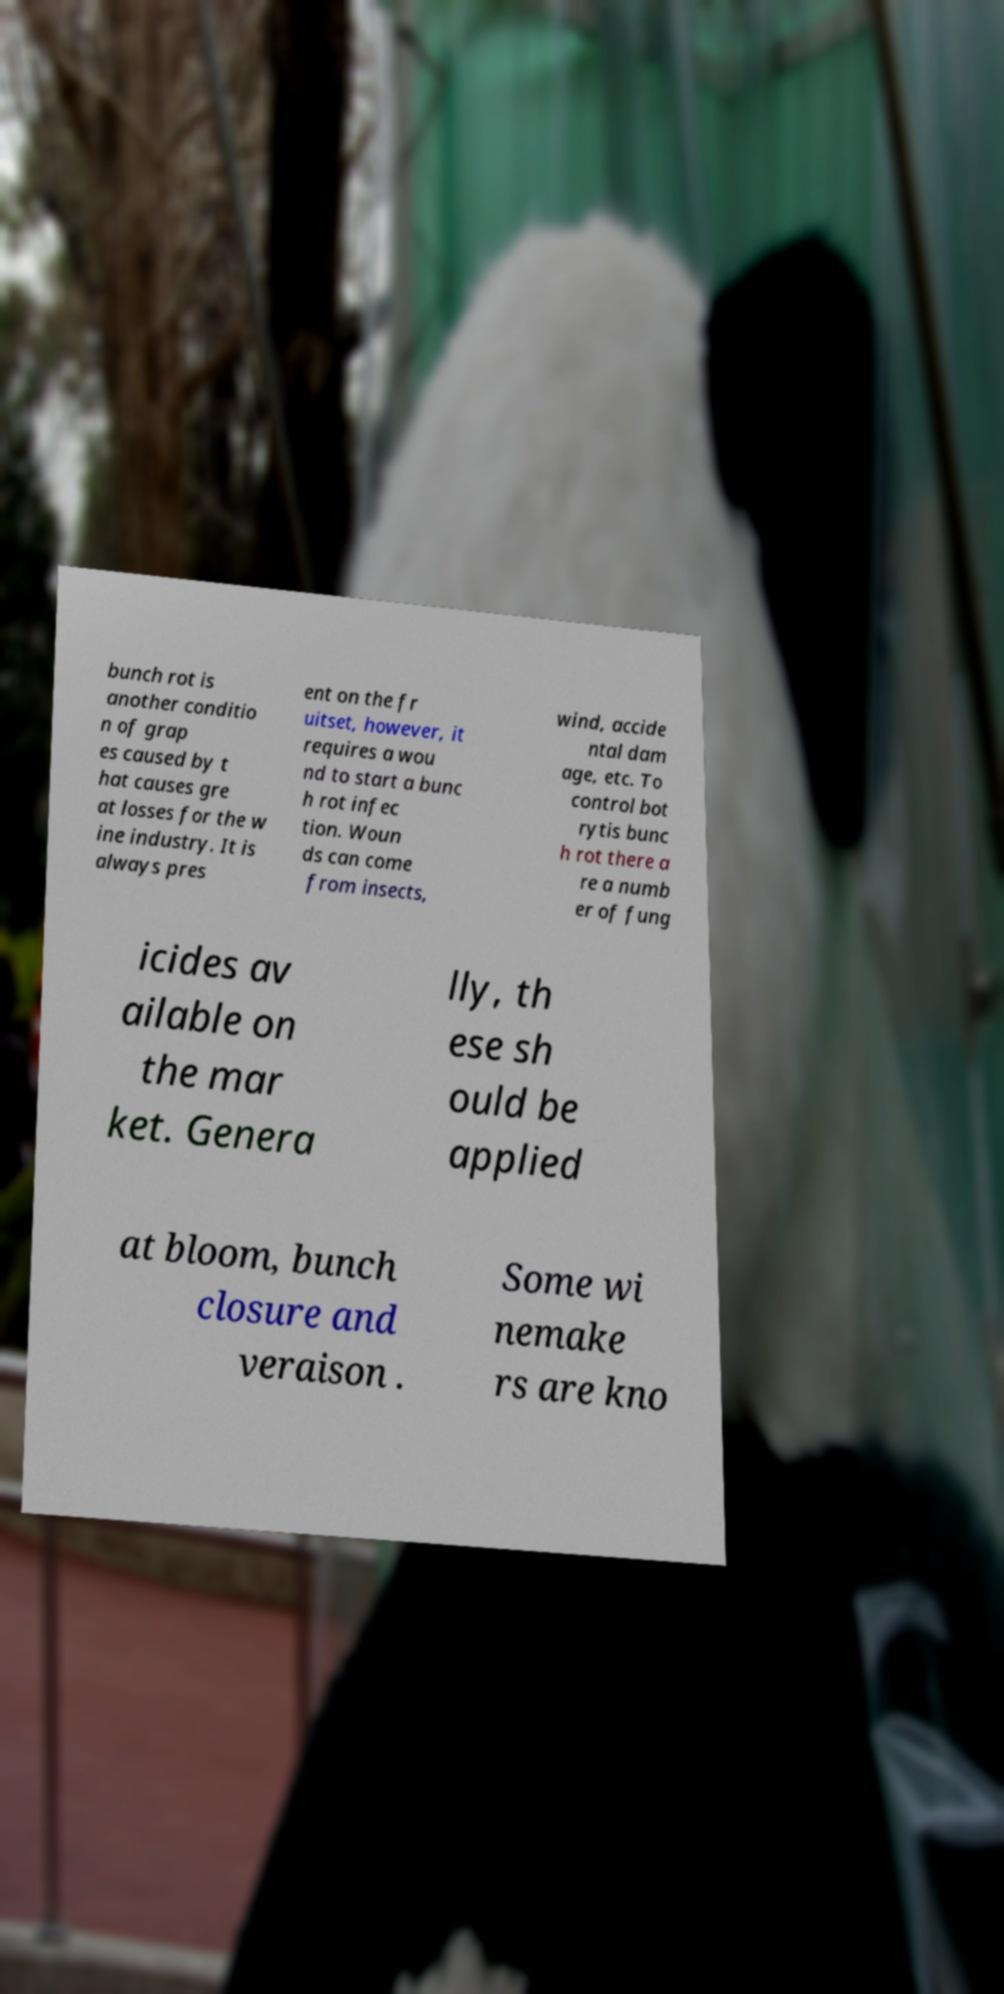Can you read and provide the text displayed in the image?This photo seems to have some interesting text. Can you extract and type it out for me? bunch rot is another conditio n of grap es caused by t hat causes gre at losses for the w ine industry. It is always pres ent on the fr uitset, however, it requires a wou nd to start a bunc h rot infec tion. Woun ds can come from insects, wind, accide ntal dam age, etc. To control bot rytis bunc h rot there a re a numb er of fung icides av ailable on the mar ket. Genera lly, th ese sh ould be applied at bloom, bunch closure and veraison . Some wi nemake rs are kno 